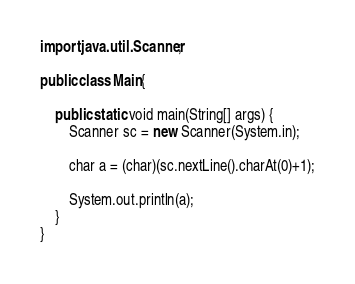<code> <loc_0><loc_0><loc_500><loc_500><_Java_>import java.util.Scanner;
 
public class Main{
 
	public static void main(String[] args) {
		Scanner sc = new Scanner(System.in);
		
		char a = (char)(sc.nextLine().charAt(0)+1);
		
		System.out.println(a);
	}
}</code> 